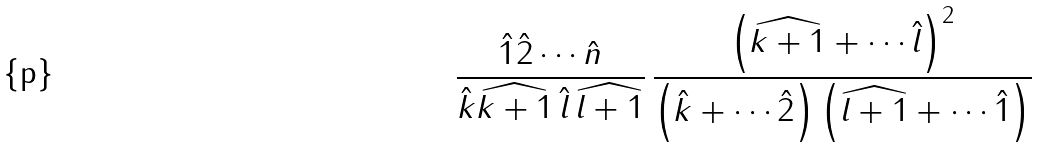<formula> <loc_0><loc_0><loc_500><loc_500>\frac { \hat { 1 } \hat { 2 } \cdots \hat { n } } { \hat { k } \widehat { k + 1 } \, \hat { l } \, \widehat { l + 1 } } \, \frac { \left ( \widehat { k + 1 } + \cdots \hat { l } \right ) ^ { 2 } } { \left ( \hat { k } + \cdots \hat { 2 } \right ) \left ( \widehat { l + 1 } + \cdots \hat { 1 } \right ) }</formula> 